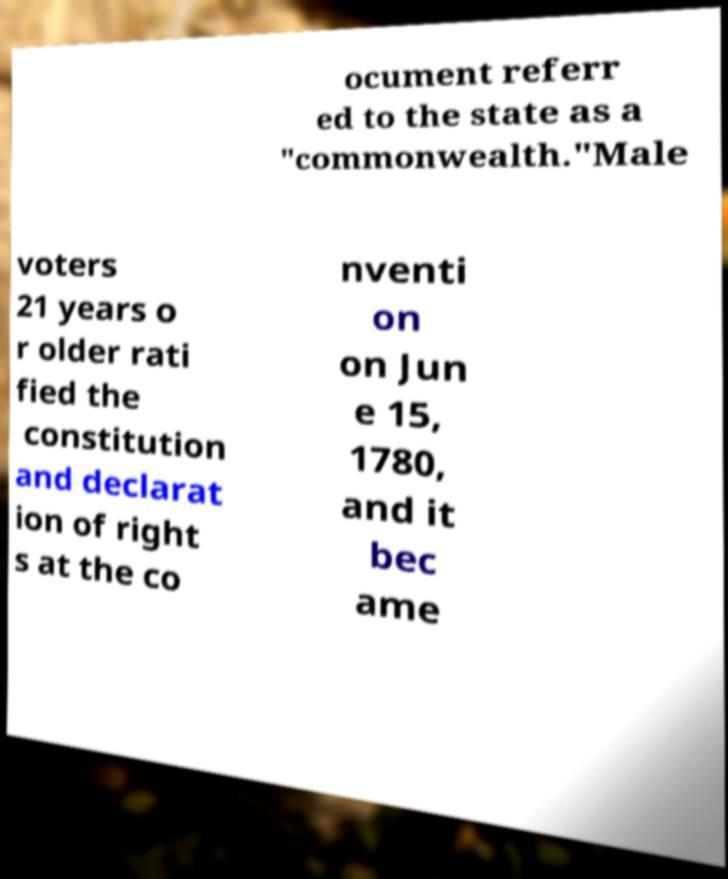I need the written content from this picture converted into text. Can you do that? ocument referr ed to the state as a "commonwealth."Male voters 21 years o r older rati fied the constitution and declarat ion of right s at the co nventi on on Jun e 15, 1780, and it bec ame 